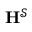Convert formula to latex. <formula><loc_0><loc_0><loc_500><loc_500>H ^ { \mathcal { S } }</formula> 